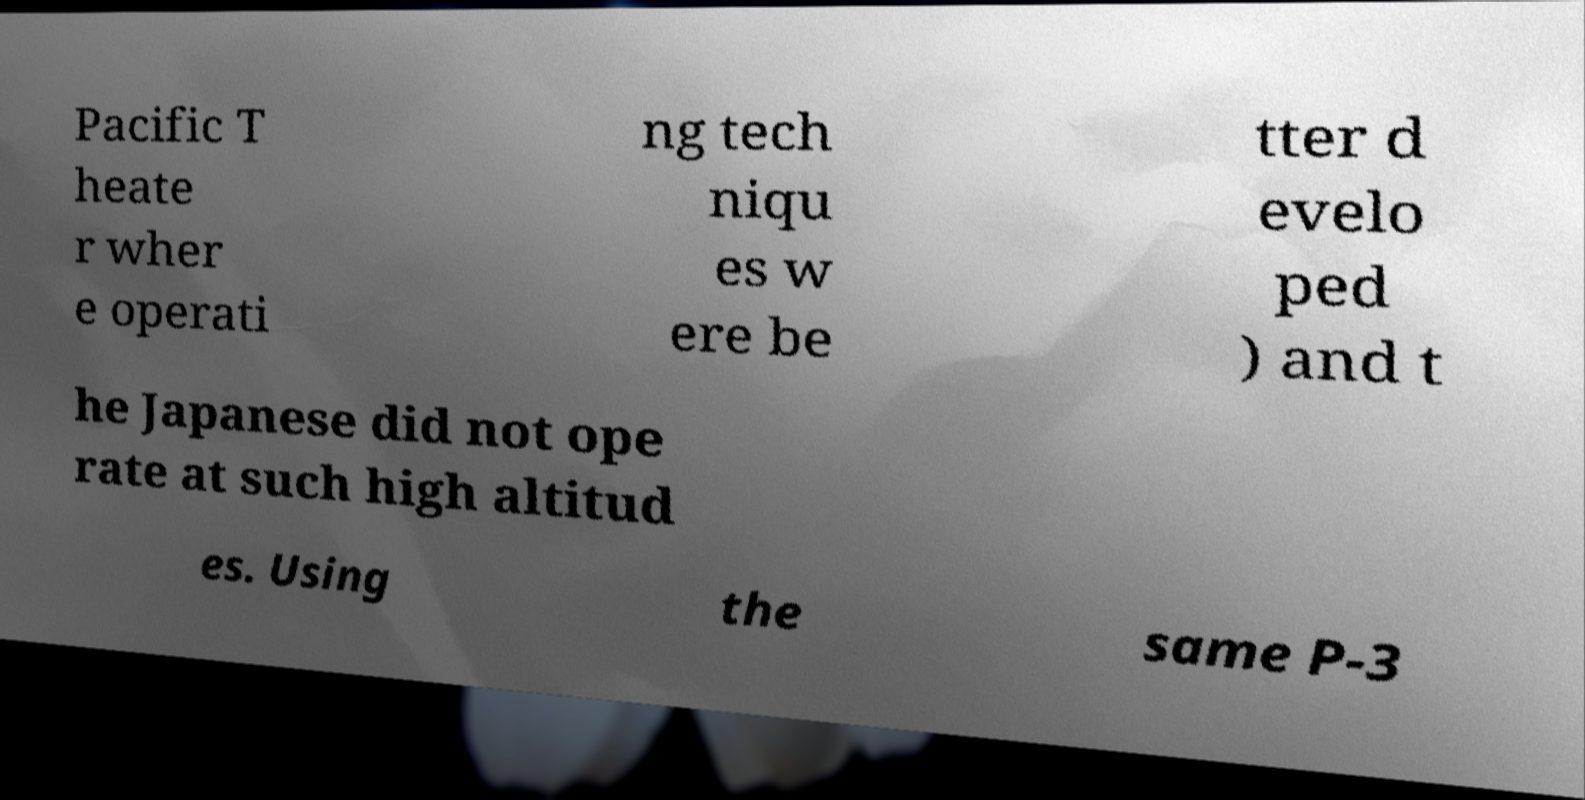Please read and relay the text visible in this image. What does it say? Pacific T heate r wher e operati ng tech niqu es w ere be tter d evelo ped ) and t he Japanese did not ope rate at such high altitud es. Using the same P-3 